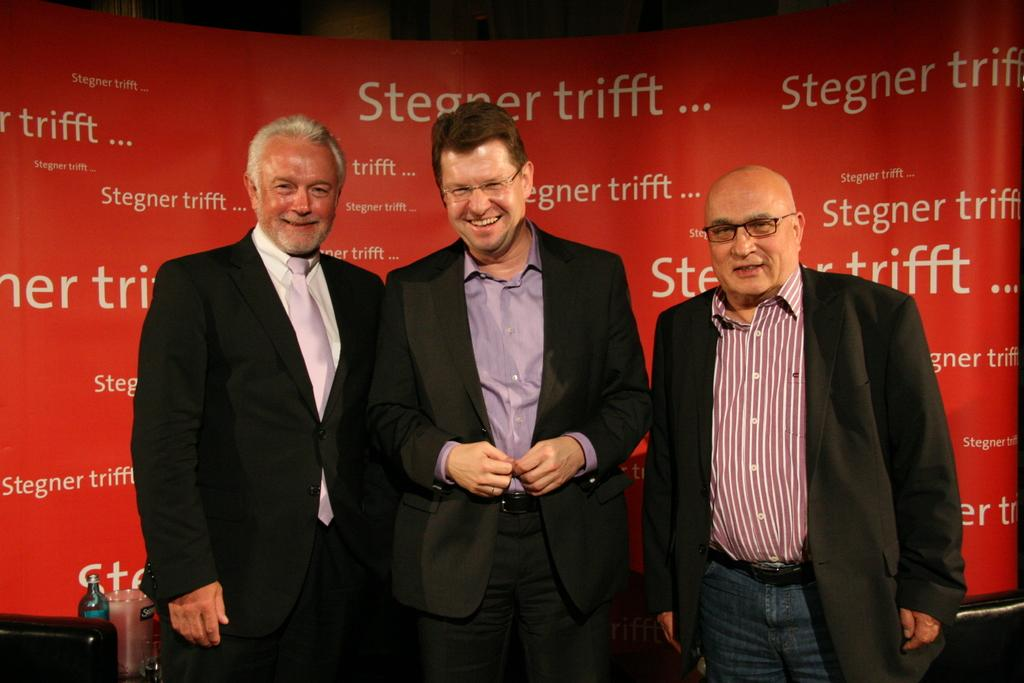How many people are in the image? There are three men standing in the image. What is the facial expression of the men in the image? The men are smiling in the image. What objects can be seen in the image besides the men? There is a bottle and a glass in the image. What color is the banner in the background of the image? There is a red banner in the background of the image. What type of thread is being used to sew the men's clothes in the image? There is no indication of thread or sewing in the image; the men's clothes are not being altered or created. 